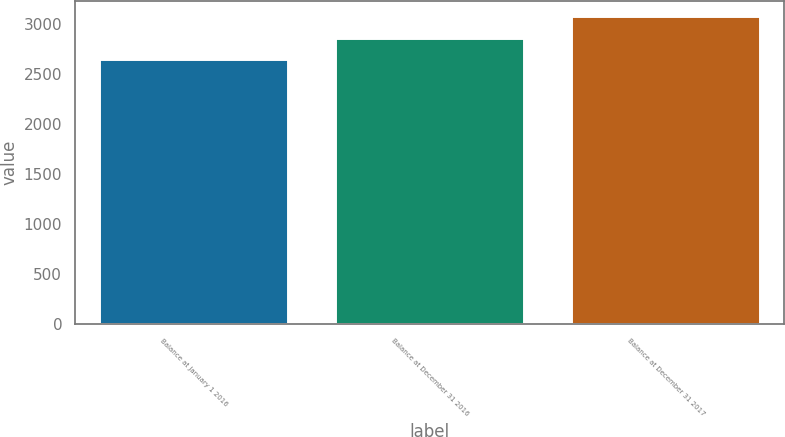<chart> <loc_0><loc_0><loc_500><loc_500><bar_chart><fcel>Balance at January 1 2016<fcel>Balance at December 31 2016<fcel>Balance at December 31 2017<nl><fcel>2648<fcel>2854<fcel>3074<nl></chart> 